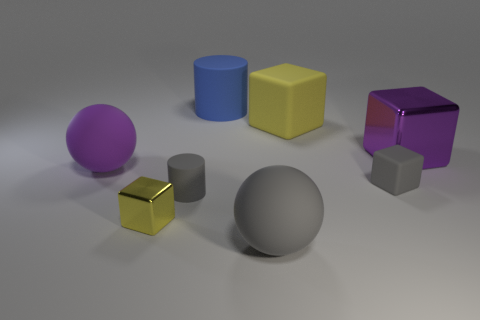Add 1 large purple matte balls. How many objects exist? 9 Subtract all balls. How many objects are left? 6 Subtract 0 blue cubes. How many objects are left? 8 Subtract all yellow rubber objects. Subtract all big blue cylinders. How many objects are left? 6 Add 6 big cylinders. How many big cylinders are left? 7 Add 3 spheres. How many spheres exist? 5 